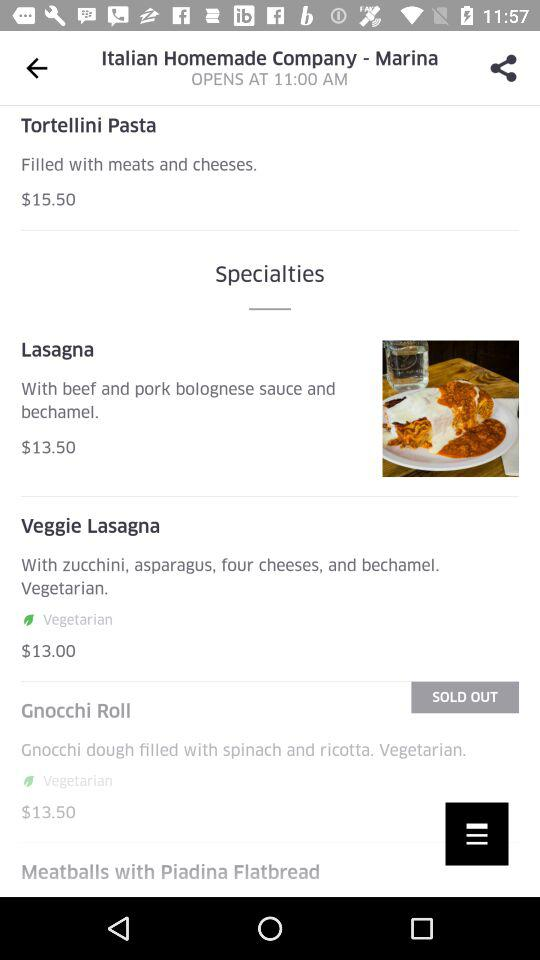Which dish is sold out? The dish that is sold out is "Gnocchi Roll". 